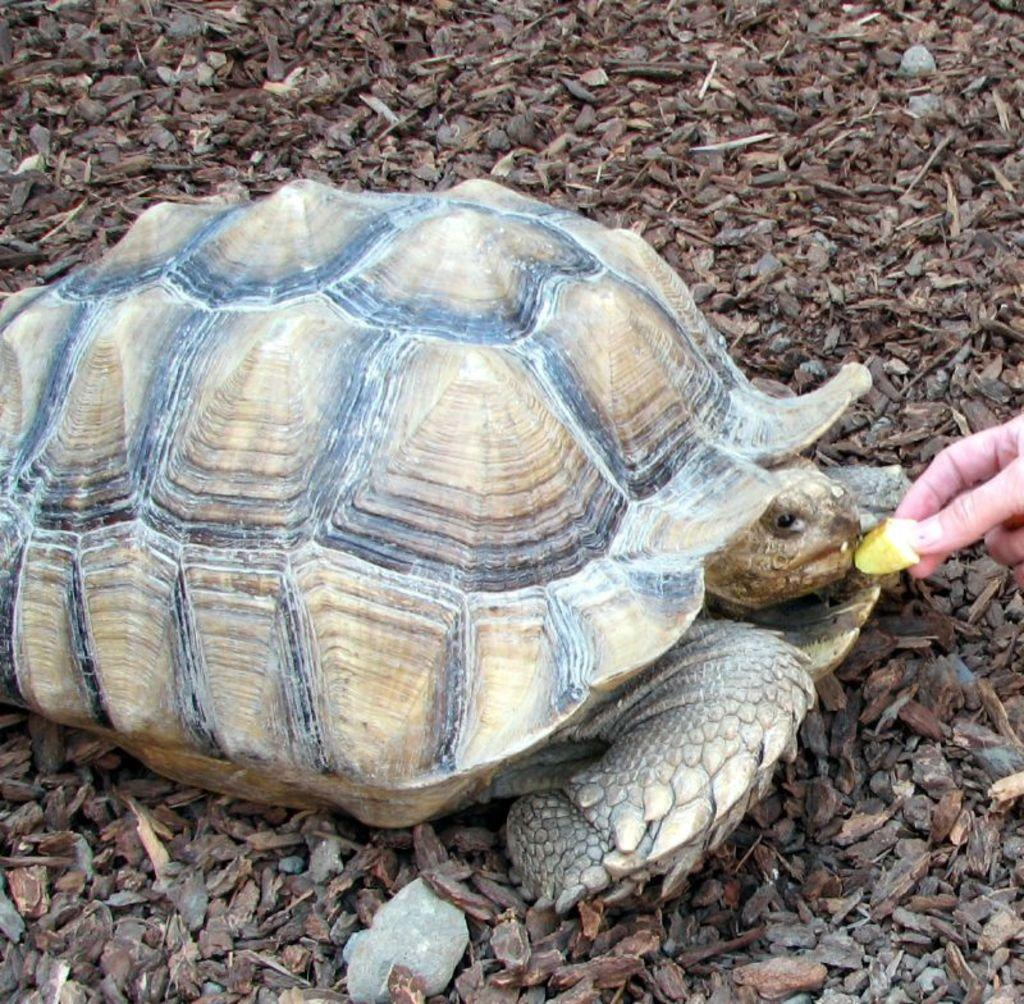What type of animal is present in the image? There is a tortoise in the image. What is happening between the human and the tortoise? A human is feeding the tortoise. What type of liquid is being used to feed the tortoise in the image? There is no liquid present in the image; the tortoise is being fed by a human. How many tortoises are present at the birth of the newborn in the image? There is no birth or newborn present in the image; it only features a tortoise and a human. 